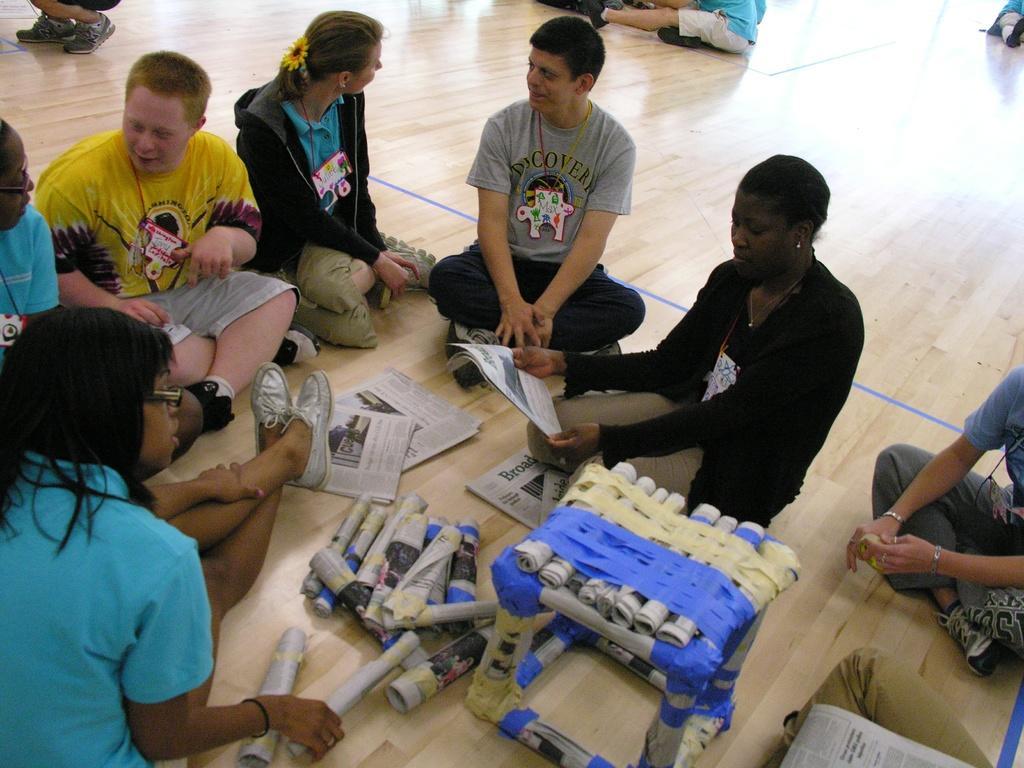In one or two sentences, can you explain what this image depicts? In this image I can see a group of people sitting on the floor. I can see a bunch of papers and paper rolls and an object made up of rolled paper. 